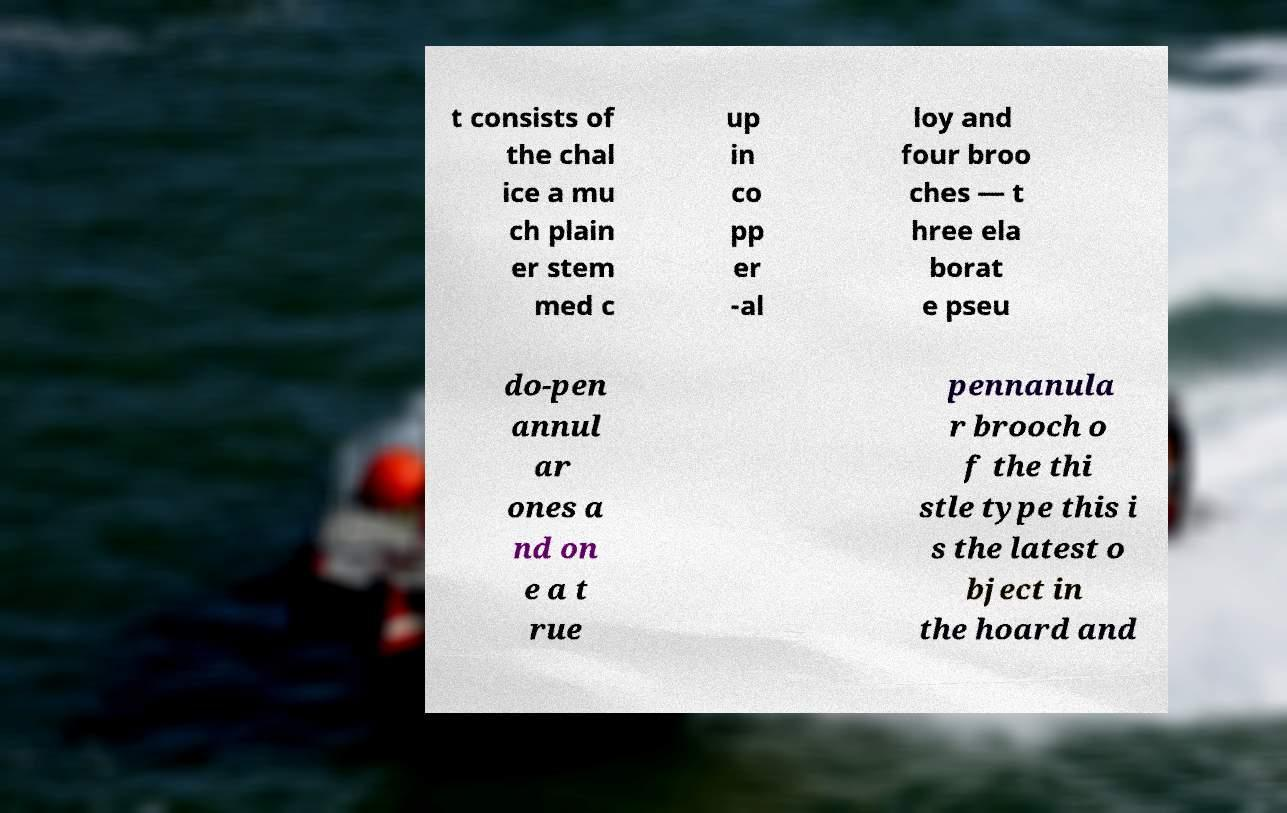For documentation purposes, I need the text within this image transcribed. Could you provide that? t consists of the chal ice a mu ch plain er stem med c up in co pp er -al loy and four broo ches — t hree ela borat e pseu do-pen annul ar ones a nd on e a t rue pennanula r brooch o f the thi stle type this i s the latest o bject in the hoard and 